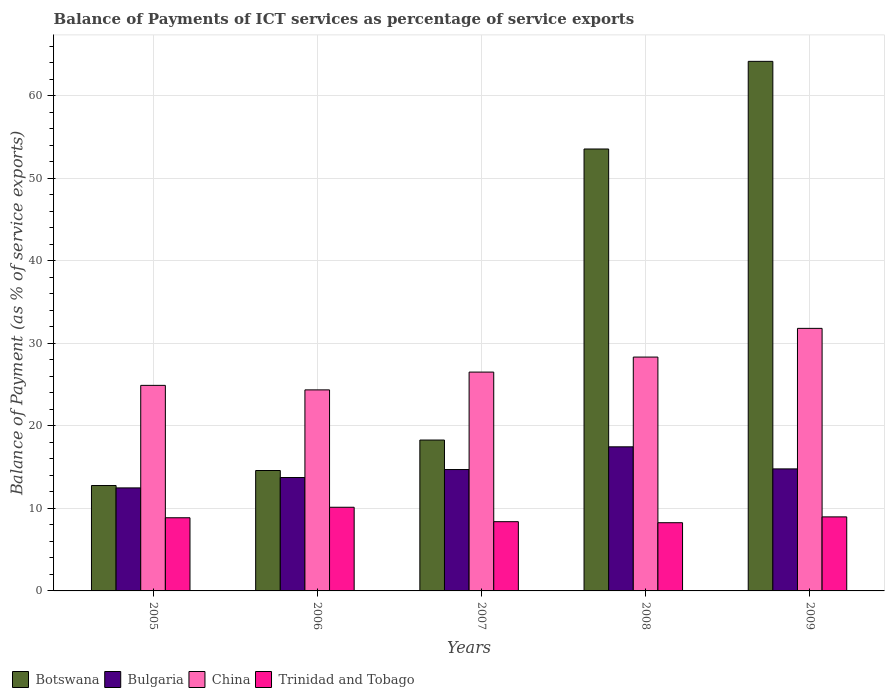How many different coloured bars are there?
Provide a short and direct response. 4. How many bars are there on the 5th tick from the right?
Make the answer very short. 4. What is the label of the 2nd group of bars from the left?
Provide a short and direct response. 2006. What is the balance of payments of ICT services in Botswana in 2007?
Your answer should be very brief. 18.28. Across all years, what is the maximum balance of payments of ICT services in Bulgaria?
Make the answer very short. 17.46. Across all years, what is the minimum balance of payments of ICT services in Botswana?
Give a very brief answer. 12.77. In which year was the balance of payments of ICT services in Bulgaria maximum?
Your response must be concise. 2008. In which year was the balance of payments of ICT services in Trinidad and Tobago minimum?
Offer a terse response. 2008. What is the total balance of payments of ICT services in Trinidad and Tobago in the graph?
Keep it short and to the point. 44.63. What is the difference between the balance of payments of ICT services in Bulgaria in 2005 and that in 2006?
Keep it short and to the point. -1.26. What is the difference between the balance of payments of ICT services in Bulgaria in 2005 and the balance of payments of ICT services in Trinidad and Tobago in 2009?
Give a very brief answer. 3.51. What is the average balance of payments of ICT services in China per year?
Ensure brevity in your answer.  27.18. In the year 2009, what is the difference between the balance of payments of ICT services in Bulgaria and balance of payments of ICT services in Trinidad and Tobago?
Offer a terse response. 5.81. What is the ratio of the balance of payments of ICT services in Bulgaria in 2005 to that in 2007?
Your answer should be compact. 0.85. Is the balance of payments of ICT services in Botswana in 2006 less than that in 2009?
Your answer should be compact. Yes. What is the difference between the highest and the second highest balance of payments of ICT services in Botswana?
Your response must be concise. 10.62. What is the difference between the highest and the lowest balance of payments of ICT services in Botswana?
Your answer should be compact. 51.39. In how many years, is the balance of payments of ICT services in Botswana greater than the average balance of payments of ICT services in Botswana taken over all years?
Your response must be concise. 2. Is it the case that in every year, the sum of the balance of payments of ICT services in Trinidad and Tobago and balance of payments of ICT services in Botswana is greater than the sum of balance of payments of ICT services in China and balance of payments of ICT services in Bulgaria?
Give a very brief answer. Yes. What does the 1st bar from the left in 2009 represents?
Make the answer very short. Botswana. What does the 2nd bar from the right in 2007 represents?
Offer a terse response. China. Is it the case that in every year, the sum of the balance of payments of ICT services in Botswana and balance of payments of ICT services in Bulgaria is greater than the balance of payments of ICT services in Trinidad and Tobago?
Ensure brevity in your answer.  Yes. How many bars are there?
Keep it short and to the point. 20. How many years are there in the graph?
Your response must be concise. 5. Are the values on the major ticks of Y-axis written in scientific E-notation?
Offer a very short reply. No. Does the graph contain any zero values?
Give a very brief answer. No. Where does the legend appear in the graph?
Ensure brevity in your answer.  Bottom left. How many legend labels are there?
Ensure brevity in your answer.  4. What is the title of the graph?
Your response must be concise. Balance of Payments of ICT services as percentage of service exports. Does "Cote d'Ivoire" appear as one of the legend labels in the graph?
Provide a succinct answer. No. What is the label or title of the X-axis?
Your answer should be very brief. Years. What is the label or title of the Y-axis?
Provide a succinct answer. Balance of Payment (as % of service exports). What is the Balance of Payment (as % of service exports) of Botswana in 2005?
Your answer should be very brief. 12.77. What is the Balance of Payment (as % of service exports) of Bulgaria in 2005?
Provide a short and direct response. 12.48. What is the Balance of Payment (as % of service exports) of China in 2005?
Your answer should be compact. 24.91. What is the Balance of Payment (as % of service exports) in Trinidad and Tobago in 2005?
Ensure brevity in your answer.  8.86. What is the Balance of Payment (as % of service exports) of Botswana in 2006?
Give a very brief answer. 14.59. What is the Balance of Payment (as % of service exports) in Bulgaria in 2006?
Provide a succinct answer. 13.74. What is the Balance of Payment (as % of service exports) of China in 2006?
Your answer should be very brief. 24.36. What is the Balance of Payment (as % of service exports) in Trinidad and Tobago in 2006?
Ensure brevity in your answer.  10.14. What is the Balance of Payment (as % of service exports) in Botswana in 2007?
Make the answer very short. 18.28. What is the Balance of Payment (as % of service exports) of Bulgaria in 2007?
Keep it short and to the point. 14.71. What is the Balance of Payment (as % of service exports) in China in 2007?
Provide a succinct answer. 26.51. What is the Balance of Payment (as % of service exports) of Trinidad and Tobago in 2007?
Your answer should be compact. 8.39. What is the Balance of Payment (as % of service exports) of Botswana in 2008?
Ensure brevity in your answer.  53.54. What is the Balance of Payment (as % of service exports) of Bulgaria in 2008?
Make the answer very short. 17.46. What is the Balance of Payment (as % of service exports) of China in 2008?
Make the answer very short. 28.33. What is the Balance of Payment (as % of service exports) in Trinidad and Tobago in 2008?
Offer a very short reply. 8.26. What is the Balance of Payment (as % of service exports) in Botswana in 2009?
Your answer should be very brief. 64.16. What is the Balance of Payment (as % of service exports) of Bulgaria in 2009?
Your answer should be very brief. 14.78. What is the Balance of Payment (as % of service exports) of China in 2009?
Your response must be concise. 31.81. What is the Balance of Payment (as % of service exports) of Trinidad and Tobago in 2009?
Offer a very short reply. 8.97. Across all years, what is the maximum Balance of Payment (as % of service exports) in Botswana?
Offer a terse response. 64.16. Across all years, what is the maximum Balance of Payment (as % of service exports) of Bulgaria?
Offer a very short reply. 17.46. Across all years, what is the maximum Balance of Payment (as % of service exports) in China?
Offer a very short reply. 31.81. Across all years, what is the maximum Balance of Payment (as % of service exports) of Trinidad and Tobago?
Provide a succinct answer. 10.14. Across all years, what is the minimum Balance of Payment (as % of service exports) in Botswana?
Give a very brief answer. 12.77. Across all years, what is the minimum Balance of Payment (as % of service exports) in Bulgaria?
Provide a succinct answer. 12.48. Across all years, what is the minimum Balance of Payment (as % of service exports) in China?
Provide a short and direct response. 24.36. Across all years, what is the minimum Balance of Payment (as % of service exports) in Trinidad and Tobago?
Your answer should be very brief. 8.26. What is the total Balance of Payment (as % of service exports) in Botswana in the graph?
Ensure brevity in your answer.  163.35. What is the total Balance of Payment (as % of service exports) in Bulgaria in the graph?
Offer a terse response. 73.17. What is the total Balance of Payment (as % of service exports) of China in the graph?
Provide a short and direct response. 135.92. What is the total Balance of Payment (as % of service exports) of Trinidad and Tobago in the graph?
Keep it short and to the point. 44.63. What is the difference between the Balance of Payment (as % of service exports) of Botswana in 2005 and that in 2006?
Make the answer very short. -1.82. What is the difference between the Balance of Payment (as % of service exports) of Bulgaria in 2005 and that in 2006?
Your answer should be very brief. -1.26. What is the difference between the Balance of Payment (as % of service exports) of China in 2005 and that in 2006?
Ensure brevity in your answer.  0.55. What is the difference between the Balance of Payment (as % of service exports) of Trinidad and Tobago in 2005 and that in 2006?
Offer a very short reply. -1.27. What is the difference between the Balance of Payment (as % of service exports) of Botswana in 2005 and that in 2007?
Your answer should be compact. -5.51. What is the difference between the Balance of Payment (as % of service exports) of Bulgaria in 2005 and that in 2007?
Offer a terse response. -2.23. What is the difference between the Balance of Payment (as % of service exports) of China in 2005 and that in 2007?
Ensure brevity in your answer.  -1.61. What is the difference between the Balance of Payment (as % of service exports) in Trinidad and Tobago in 2005 and that in 2007?
Make the answer very short. 0.47. What is the difference between the Balance of Payment (as % of service exports) of Botswana in 2005 and that in 2008?
Give a very brief answer. -40.77. What is the difference between the Balance of Payment (as % of service exports) of Bulgaria in 2005 and that in 2008?
Give a very brief answer. -4.98. What is the difference between the Balance of Payment (as % of service exports) of China in 2005 and that in 2008?
Offer a terse response. -3.43. What is the difference between the Balance of Payment (as % of service exports) of Trinidad and Tobago in 2005 and that in 2008?
Your answer should be compact. 0.6. What is the difference between the Balance of Payment (as % of service exports) in Botswana in 2005 and that in 2009?
Offer a terse response. -51.39. What is the difference between the Balance of Payment (as % of service exports) in Bulgaria in 2005 and that in 2009?
Offer a terse response. -2.3. What is the difference between the Balance of Payment (as % of service exports) in China in 2005 and that in 2009?
Provide a succinct answer. -6.91. What is the difference between the Balance of Payment (as % of service exports) in Trinidad and Tobago in 2005 and that in 2009?
Provide a succinct answer. -0.11. What is the difference between the Balance of Payment (as % of service exports) of Botswana in 2006 and that in 2007?
Give a very brief answer. -3.69. What is the difference between the Balance of Payment (as % of service exports) of Bulgaria in 2006 and that in 2007?
Offer a very short reply. -0.97. What is the difference between the Balance of Payment (as % of service exports) of China in 2006 and that in 2007?
Your answer should be compact. -2.16. What is the difference between the Balance of Payment (as % of service exports) of Trinidad and Tobago in 2006 and that in 2007?
Provide a succinct answer. 1.75. What is the difference between the Balance of Payment (as % of service exports) of Botswana in 2006 and that in 2008?
Your answer should be compact. -38.95. What is the difference between the Balance of Payment (as % of service exports) in Bulgaria in 2006 and that in 2008?
Provide a short and direct response. -3.72. What is the difference between the Balance of Payment (as % of service exports) of China in 2006 and that in 2008?
Provide a succinct answer. -3.98. What is the difference between the Balance of Payment (as % of service exports) in Trinidad and Tobago in 2006 and that in 2008?
Your answer should be compact. 1.87. What is the difference between the Balance of Payment (as % of service exports) of Botswana in 2006 and that in 2009?
Keep it short and to the point. -49.57. What is the difference between the Balance of Payment (as % of service exports) of Bulgaria in 2006 and that in 2009?
Give a very brief answer. -1.05. What is the difference between the Balance of Payment (as % of service exports) of China in 2006 and that in 2009?
Your answer should be very brief. -7.45. What is the difference between the Balance of Payment (as % of service exports) in Trinidad and Tobago in 2006 and that in 2009?
Your answer should be very brief. 1.17. What is the difference between the Balance of Payment (as % of service exports) of Botswana in 2007 and that in 2008?
Your answer should be compact. -35.26. What is the difference between the Balance of Payment (as % of service exports) in Bulgaria in 2007 and that in 2008?
Your response must be concise. -2.75. What is the difference between the Balance of Payment (as % of service exports) of China in 2007 and that in 2008?
Your answer should be very brief. -1.82. What is the difference between the Balance of Payment (as % of service exports) of Trinidad and Tobago in 2007 and that in 2008?
Your answer should be very brief. 0.12. What is the difference between the Balance of Payment (as % of service exports) in Botswana in 2007 and that in 2009?
Give a very brief answer. -45.88. What is the difference between the Balance of Payment (as % of service exports) in Bulgaria in 2007 and that in 2009?
Offer a terse response. -0.08. What is the difference between the Balance of Payment (as % of service exports) in China in 2007 and that in 2009?
Ensure brevity in your answer.  -5.3. What is the difference between the Balance of Payment (as % of service exports) of Trinidad and Tobago in 2007 and that in 2009?
Give a very brief answer. -0.58. What is the difference between the Balance of Payment (as % of service exports) in Botswana in 2008 and that in 2009?
Your response must be concise. -10.62. What is the difference between the Balance of Payment (as % of service exports) in Bulgaria in 2008 and that in 2009?
Provide a succinct answer. 2.67. What is the difference between the Balance of Payment (as % of service exports) in China in 2008 and that in 2009?
Provide a short and direct response. -3.48. What is the difference between the Balance of Payment (as % of service exports) in Trinidad and Tobago in 2008 and that in 2009?
Offer a very short reply. -0.7. What is the difference between the Balance of Payment (as % of service exports) in Botswana in 2005 and the Balance of Payment (as % of service exports) in Bulgaria in 2006?
Make the answer very short. -0.97. What is the difference between the Balance of Payment (as % of service exports) in Botswana in 2005 and the Balance of Payment (as % of service exports) in China in 2006?
Offer a terse response. -11.59. What is the difference between the Balance of Payment (as % of service exports) in Botswana in 2005 and the Balance of Payment (as % of service exports) in Trinidad and Tobago in 2006?
Offer a very short reply. 2.63. What is the difference between the Balance of Payment (as % of service exports) of Bulgaria in 2005 and the Balance of Payment (as % of service exports) of China in 2006?
Provide a succinct answer. -11.88. What is the difference between the Balance of Payment (as % of service exports) of Bulgaria in 2005 and the Balance of Payment (as % of service exports) of Trinidad and Tobago in 2006?
Give a very brief answer. 2.34. What is the difference between the Balance of Payment (as % of service exports) of China in 2005 and the Balance of Payment (as % of service exports) of Trinidad and Tobago in 2006?
Give a very brief answer. 14.77. What is the difference between the Balance of Payment (as % of service exports) of Botswana in 2005 and the Balance of Payment (as % of service exports) of Bulgaria in 2007?
Offer a terse response. -1.94. What is the difference between the Balance of Payment (as % of service exports) of Botswana in 2005 and the Balance of Payment (as % of service exports) of China in 2007?
Your answer should be very brief. -13.74. What is the difference between the Balance of Payment (as % of service exports) of Botswana in 2005 and the Balance of Payment (as % of service exports) of Trinidad and Tobago in 2007?
Offer a terse response. 4.38. What is the difference between the Balance of Payment (as % of service exports) in Bulgaria in 2005 and the Balance of Payment (as % of service exports) in China in 2007?
Ensure brevity in your answer.  -14.03. What is the difference between the Balance of Payment (as % of service exports) of Bulgaria in 2005 and the Balance of Payment (as % of service exports) of Trinidad and Tobago in 2007?
Ensure brevity in your answer.  4.09. What is the difference between the Balance of Payment (as % of service exports) in China in 2005 and the Balance of Payment (as % of service exports) in Trinidad and Tobago in 2007?
Ensure brevity in your answer.  16.52. What is the difference between the Balance of Payment (as % of service exports) in Botswana in 2005 and the Balance of Payment (as % of service exports) in Bulgaria in 2008?
Your answer should be compact. -4.69. What is the difference between the Balance of Payment (as % of service exports) in Botswana in 2005 and the Balance of Payment (as % of service exports) in China in 2008?
Keep it short and to the point. -15.56. What is the difference between the Balance of Payment (as % of service exports) of Botswana in 2005 and the Balance of Payment (as % of service exports) of Trinidad and Tobago in 2008?
Provide a succinct answer. 4.51. What is the difference between the Balance of Payment (as % of service exports) in Bulgaria in 2005 and the Balance of Payment (as % of service exports) in China in 2008?
Offer a very short reply. -15.85. What is the difference between the Balance of Payment (as % of service exports) of Bulgaria in 2005 and the Balance of Payment (as % of service exports) of Trinidad and Tobago in 2008?
Ensure brevity in your answer.  4.22. What is the difference between the Balance of Payment (as % of service exports) of China in 2005 and the Balance of Payment (as % of service exports) of Trinidad and Tobago in 2008?
Your answer should be very brief. 16.64. What is the difference between the Balance of Payment (as % of service exports) in Botswana in 2005 and the Balance of Payment (as % of service exports) in Bulgaria in 2009?
Give a very brief answer. -2.01. What is the difference between the Balance of Payment (as % of service exports) of Botswana in 2005 and the Balance of Payment (as % of service exports) of China in 2009?
Give a very brief answer. -19.04. What is the difference between the Balance of Payment (as % of service exports) in Botswana in 2005 and the Balance of Payment (as % of service exports) in Trinidad and Tobago in 2009?
Provide a short and direct response. 3.8. What is the difference between the Balance of Payment (as % of service exports) of Bulgaria in 2005 and the Balance of Payment (as % of service exports) of China in 2009?
Offer a very short reply. -19.33. What is the difference between the Balance of Payment (as % of service exports) in Bulgaria in 2005 and the Balance of Payment (as % of service exports) in Trinidad and Tobago in 2009?
Offer a terse response. 3.51. What is the difference between the Balance of Payment (as % of service exports) in China in 2005 and the Balance of Payment (as % of service exports) in Trinidad and Tobago in 2009?
Make the answer very short. 15.94. What is the difference between the Balance of Payment (as % of service exports) of Botswana in 2006 and the Balance of Payment (as % of service exports) of Bulgaria in 2007?
Offer a very short reply. -0.12. What is the difference between the Balance of Payment (as % of service exports) of Botswana in 2006 and the Balance of Payment (as % of service exports) of China in 2007?
Provide a succinct answer. -11.92. What is the difference between the Balance of Payment (as % of service exports) in Botswana in 2006 and the Balance of Payment (as % of service exports) in Trinidad and Tobago in 2007?
Offer a terse response. 6.2. What is the difference between the Balance of Payment (as % of service exports) of Bulgaria in 2006 and the Balance of Payment (as % of service exports) of China in 2007?
Keep it short and to the point. -12.78. What is the difference between the Balance of Payment (as % of service exports) of Bulgaria in 2006 and the Balance of Payment (as % of service exports) of Trinidad and Tobago in 2007?
Keep it short and to the point. 5.35. What is the difference between the Balance of Payment (as % of service exports) of China in 2006 and the Balance of Payment (as % of service exports) of Trinidad and Tobago in 2007?
Provide a succinct answer. 15.97. What is the difference between the Balance of Payment (as % of service exports) of Botswana in 2006 and the Balance of Payment (as % of service exports) of Bulgaria in 2008?
Provide a succinct answer. -2.87. What is the difference between the Balance of Payment (as % of service exports) in Botswana in 2006 and the Balance of Payment (as % of service exports) in China in 2008?
Your answer should be very brief. -13.74. What is the difference between the Balance of Payment (as % of service exports) in Botswana in 2006 and the Balance of Payment (as % of service exports) in Trinidad and Tobago in 2008?
Make the answer very short. 6.33. What is the difference between the Balance of Payment (as % of service exports) in Bulgaria in 2006 and the Balance of Payment (as % of service exports) in China in 2008?
Ensure brevity in your answer.  -14.6. What is the difference between the Balance of Payment (as % of service exports) in Bulgaria in 2006 and the Balance of Payment (as % of service exports) in Trinidad and Tobago in 2008?
Offer a very short reply. 5.47. What is the difference between the Balance of Payment (as % of service exports) of China in 2006 and the Balance of Payment (as % of service exports) of Trinidad and Tobago in 2008?
Provide a succinct answer. 16.09. What is the difference between the Balance of Payment (as % of service exports) of Botswana in 2006 and the Balance of Payment (as % of service exports) of Bulgaria in 2009?
Provide a succinct answer. -0.19. What is the difference between the Balance of Payment (as % of service exports) in Botswana in 2006 and the Balance of Payment (as % of service exports) in China in 2009?
Offer a terse response. -17.22. What is the difference between the Balance of Payment (as % of service exports) in Botswana in 2006 and the Balance of Payment (as % of service exports) in Trinidad and Tobago in 2009?
Provide a succinct answer. 5.62. What is the difference between the Balance of Payment (as % of service exports) of Bulgaria in 2006 and the Balance of Payment (as % of service exports) of China in 2009?
Provide a succinct answer. -18.07. What is the difference between the Balance of Payment (as % of service exports) of Bulgaria in 2006 and the Balance of Payment (as % of service exports) of Trinidad and Tobago in 2009?
Ensure brevity in your answer.  4.77. What is the difference between the Balance of Payment (as % of service exports) of China in 2006 and the Balance of Payment (as % of service exports) of Trinidad and Tobago in 2009?
Your answer should be compact. 15.39. What is the difference between the Balance of Payment (as % of service exports) of Botswana in 2007 and the Balance of Payment (as % of service exports) of Bulgaria in 2008?
Keep it short and to the point. 0.82. What is the difference between the Balance of Payment (as % of service exports) of Botswana in 2007 and the Balance of Payment (as % of service exports) of China in 2008?
Your response must be concise. -10.05. What is the difference between the Balance of Payment (as % of service exports) in Botswana in 2007 and the Balance of Payment (as % of service exports) in Trinidad and Tobago in 2008?
Ensure brevity in your answer.  10.02. What is the difference between the Balance of Payment (as % of service exports) of Bulgaria in 2007 and the Balance of Payment (as % of service exports) of China in 2008?
Your answer should be compact. -13.63. What is the difference between the Balance of Payment (as % of service exports) of Bulgaria in 2007 and the Balance of Payment (as % of service exports) of Trinidad and Tobago in 2008?
Keep it short and to the point. 6.44. What is the difference between the Balance of Payment (as % of service exports) of China in 2007 and the Balance of Payment (as % of service exports) of Trinidad and Tobago in 2008?
Keep it short and to the point. 18.25. What is the difference between the Balance of Payment (as % of service exports) in Botswana in 2007 and the Balance of Payment (as % of service exports) in Bulgaria in 2009?
Your answer should be very brief. 3.5. What is the difference between the Balance of Payment (as % of service exports) in Botswana in 2007 and the Balance of Payment (as % of service exports) in China in 2009?
Provide a short and direct response. -13.53. What is the difference between the Balance of Payment (as % of service exports) in Botswana in 2007 and the Balance of Payment (as % of service exports) in Trinidad and Tobago in 2009?
Your response must be concise. 9.31. What is the difference between the Balance of Payment (as % of service exports) of Bulgaria in 2007 and the Balance of Payment (as % of service exports) of China in 2009?
Offer a terse response. -17.1. What is the difference between the Balance of Payment (as % of service exports) of Bulgaria in 2007 and the Balance of Payment (as % of service exports) of Trinidad and Tobago in 2009?
Your response must be concise. 5.74. What is the difference between the Balance of Payment (as % of service exports) in China in 2007 and the Balance of Payment (as % of service exports) in Trinidad and Tobago in 2009?
Ensure brevity in your answer.  17.54. What is the difference between the Balance of Payment (as % of service exports) of Botswana in 2008 and the Balance of Payment (as % of service exports) of Bulgaria in 2009?
Your response must be concise. 38.76. What is the difference between the Balance of Payment (as % of service exports) in Botswana in 2008 and the Balance of Payment (as % of service exports) in China in 2009?
Ensure brevity in your answer.  21.73. What is the difference between the Balance of Payment (as % of service exports) in Botswana in 2008 and the Balance of Payment (as % of service exports) in Trinidad and Tobago in 2009?
Make the answer very short. 44.57. What is the difference between the Balance of Payment (as % of service exports) of Bulgaria in 2008 and the Balance of Payment (as % of service exports) of China in 2009?
Offer a very short reply. -14.35. What is the difference between the Balance of Payment (as % of service exports) in Bulgaria in 2008 and the Balance of Payment (as % of service exports) in Trinidad and Tobago in 2009?
Ensure brevity in your answer.  8.49. What is the difference between the Balance of Payment (as % of service exports) in China in 2008 and the Balance of Payment (as % of service exports) in Trinidad and Tobago in 2009?
Provide a short and direct response. 19.36. What is the average Balance of Payment (as % of service exports) of Botswana per year?
Your answer should be compact. 32.67. What is the average Balance of Payment (as % of service exports) of Bulgaria per year?
Provide a succinct answer. 14.63. What is the average Balance of Payment (as % of service exports) of China per year?
Give a very brief answer. 27.18. What is the average Balance of Payment (as % of service exports) in Trinidad and Tobago per year?
Ensure brevity in your answer.  8.93. In the year 2005, what is the difference between the Balance of Payment (as % of service exports) in Botswana and Balance of Payment (as % of service exports) in Bulgaria?
Keep it short and to the point. 0.29. In the year 2005, what is the difference between the Balance of Payment (as % of service exports) in Botswana and Balance of Payment (as % of service exports) in China?
Give a very brief answer. -12.13. In the year 2005, what is the difference between the Balance of Payment (as % of service exports) in Botswana and Balance of Payment (as % of service exports) in Trinidad and Tobago?
Your response must be concise. 3.91. In the year 2005, what is the difference between the Balance of Payment (as % of service exports) in Bulgaria and Balance of Payment (as % of service exports) in China?
Your response must be concise. -12.42. In the year 2005, what is the difference between the Balance of Payment (as % of service exports) in Bulgaria and Balance of Payment (as % of service exports) in Trinidad and Tobago?
Your response must be concise. 3.62. In the year 2005, what is the difference between the Balance of Payment (as % of service exports) in China and Balance of Payment (as % of service exports) in Trinidad and Tobago?
Your answer should be compact. 16.04. In the year 2006, what is the difference between the Balance of Payment (as % of service exports) in Botswana and Balance of Payment (as % of service exports) in Bulgaria?
Your response must be concise. 0.85. In the year 2006, what is the difference between the Balance of Payment (as % of service exports) in Botswana and Balance of Payment (as % of service exports) in China?
Your answer should be compact. -9.77. In the year 2006, what is the difference between the Balance of Payment (as % of service exports) in Botswana and Balance of Payment (as % of service exports) in Trinidad and Tobago?
Provide a short and direct response. 4.45. In the year 2006, what is the difference between the Balance of Payment (as % of service exports) of Bulgaria and Balance of Payment (as % of service exports) of China?
Offer a terse response. -10.62. In the year 2006, what is the difference between the Balance of Payment (as % of service exports) of Bulgaria and Balance of Payment (as % of service exports) of Trinidad and Tobago?
Provide a short and direct response. 3.6. In the year 2006, what is the difference between the Balance of Payment (as % of service exports) in China and Balance of Payment (as % of service exports) in Trinidad and Tobago?
Your answer should be very brief. 14.22. In the year 2007, what is the difference between the Balance of Payment (as % of service exports) in Botswana and Balance of Payment (as % of service exports) in Bulgaria?
Your response must be concise. 3.57. In the year 2007, what is the difference between the Balance of Payment (as % of service exports) in Botswana and Balance of Payment (as % of service exports) in China?
Your response must be concise. -8.23. In the year 2007, what is the difference between the Balance of Payment (as % of service exports) in Botswana and Balance of Payment (as % of service exports) in Trinidad and Tobago?
Make the answer very short. 9.89. In the year 2007, what is the difference between the Balance of Payment (as % of service exports) in Bulgaria and Balance of Payment (as % of service exports) in China?
Your response must be concise. -11.81. In the year 2007, what is the difference between the Balance of Payment (as % of service exports) of Bulgaria and Balance of Payment (as % of service exports) of Trinidad and Tobago?
Your answer should be very brief. 6.32. In the year 2007, what is the difference between the Balance of Payment (as % of service exports) of China and Balance of Payment (as % of service exports) of Trinidad and Tobago?
Your response must be concise. 18.12. In the year 2008, what is the difference between the Balance of Payment (as % of service exports) in Botswana and Balance of Payment (as % of service exports) in Bulgaria?
Make the answer very short. 36.09. In the year 2008, what is the difference between the Balance of Payment (as % of service exports) in Botswana and Balance of Payment (as % of service exports) in China?
Ensure brevity in your answer.  25.21. In the year 2008, what is the difference between the Balance of Payment (as % of service exports) in Botswana and Balance of Payment (as % of service exports) in Trinidad and Tobago?
Offer a very short reply. 45.28. In the year 2008, what is the difference between the Balance of Payment (as % of service exports) of Bulgaria and Balance of Payment (as % of service exports) of China?
Your answer should be compact. -10.88. In the year 2008, what is the difference between the Balance of Payment (as % of service exports) of Bulgaria and Balance of Payment (as % of service exports) of Trinidad and Tobago?
Keep it short and to the point. 9.19. In the year 2008, what is the difference between the Balance of Payment (as % of service exports) of China and Balance of Payment (as % of service exports) of Trinidad and Tobago?
Offer a terse response. 20.07. In the year 2009, what is the difference between the Balance of Payment (as % of service exports) in Botswana and Balance of Payment (as % of service exports) in Bulgaria?
Your answer should be very brief. 49.38. In the year 2009, what is the difference between the Balance of Payment (as % of service exports) in Botswana and Balance of Payment (as % of service exports) in China?
Ensure brevity in your answer.  32.35. In the year 2009, what is the difference between the Balance of Payment (as % of service exports) of Botswana and Balance of Payment (as % of service exports) of Trinidad and Tobago?
Your response must be concise. 55.19. In the year 2009, what is the difference between the Balance of Payment (as % of service exports) of Bulgaria and Balance of Payment (as % of service exports) of China?
Provide a short and direct response. -17.03. In the year 2009, what is the difference between the Balance of Payment (as % of service exports) in Bulgaria and Balance of Payment (as % of service exports) in Trinidad and Tobago?
Your answer should be compact. 5.82. In the year 2009, what is the difference between the Balance of Payment (as % of service exports) in China and Balance of Payment (as % of service exports) in Trinidad and Tobago?
Your answer should be very brief. 22.84. What is the ratio of the Balance of Payment (as % of service exports) in Botswana in 2005 to that in 2006?
Ensure brevity in your answer.  0.88. What is the ratio of the Balance of Payment (as % of service exports) of Bulgaria in 2005 to that in 2006?
Your answer should be very brief. 0.91. What is the ratio of the Balance of Payment (as % of service exports) of China in 2005 to that in 2006?
Make the answer very short. 1.02. What is the ratio of the Balance of Payment (as % of service exports) in Trinidad and Tobago in 2005 to that in 2006?
Offer a terse response. 0.87. What is the ratio of the Balance of Payment (as % of service exports) of Botswana in 2005 to that in 2007?
Your answer should be very brief. 0.7. What is the ratio of the Balance of Payment (as % of service exports) of Bulgaria in 2005 to that in 2007?
Your answer should be compact. 0.85. What is the ratio of the Balance of Payment (as % of service exports) of China in 2005 to that in 2007?
Make the answer very short. 0.94. What is the ratio of the Balance of Payment (as % of service exports) of Trinidad and Tobago in 2005 to that in 2007?
Your response must be concise. 1.06. What is the ratio of the Balance of Payment (as % of service exports) in Botswana in 2005 to that in 2008?
Provide a succinct answer. 0.24. What is the ratio of the Balance of Payment (as % of service exports) in Bulgaria in 2005 to that in 2008?
Your answer should be compact. 0.71. What is the ratio of the Balance of Payment (as % of service exports) in China in 2005 to that in 2008?
Provide a short and direct response. 0.88. What is the ratio of the Balance of Payment (as % of service exports) in Trinidad and Tobago in 2005 to that in 2008?
Give a very brief answer. 1.07. What is the ratio of the Balance of Payment (as % of service exports) in Botswana in 2005 to that in 2009?
Your answer should be very brief. 0.2. What is the ratio of the Balance of Payment (as % of service exports) of Bulgaria in 2005 to that in 2009?
Provide a succinct answer. 0.84. What is the ratio of the Balance of Payment (as % of service exports) of China in 2005 to that in 2009?
Offer a terse response. 0.78. What is the ratio of the Balance of Payment (as % of service exports) in Botswana in 2006 to that in 2007?
Give a very brief answer. 0.8. What is the ratio of the Balance of Payment (as % of service exports) of Bulgaria in 2006 to that in 2007?
Ensure brevity in your answer.  0.93. What is the ratio of the Balance of Payment (as % of service exports) of China in 2006 to that in 2007?
Your answer should be very brief. 0.92. What is the ratio of the Balance of Payment (as % of service exports) of Trinidad and Tobago in 2006 to that in 2007?
Offer a very short reply. 1.21. What is the ratio of the Balance of Payment (as % of service exports) in Botswana in 2006 to that in 2008?
Your answer should be compact. 0.27. What is the ratio of the Balance of Payment (as % of service exports) of Bulgaria in 2006 to that in 2008?
Ensure brevity in your answer.  0.79. What is the ratio of the Balance of Payment (as % of service exports) in China in 2006 to that in 2008?
Ensure brevity in your answer.  0.86. What is the ratio of the Balance of Payment (as % of service exports) in Trinidad and Tobago in 2006 to that in 2008?
Your answer should be compact. 1.23. What is the ratio of the Balance of Payment (as % of service exports) in Botswana in 2006 to that in 2009?
Offer a very short reply. 0.23. What is the ratio of the Balance of Payment (as % of service exports) in Bulgaria in 2006 to that in 2009?
Your response must be concise. 0.93. What is the ratio of the Balance of Payment (as % of service exports) in China in 2006 to that in 2009?
Your response must be concise. 0.77. What is the ratio of the Balance of Payment (as % of service exports) of Trinidad and Tobago in 2006 to that in 2009?
Keep it short and to the point. 1.13. What is the ratio of the Balance of Payment (as % of service exports) of Botswana in 2007 to that in 2008?
Your response must be concise. 0.34. What is the ratio of the Balance of Payment (as % of service exports) of Bulgaria in 2007 to that in 2008?
Provide a succinct answer. 0.84. What is the ratio of the Balance of Payment (as % of service exports) in China in 2007 to that in 2008?
Make the answer very short. 0.94. What is the ratio of the Balance of Payment (as % of service exports) of Trinidad and Tobago in 2007 to that in 2008?
Offer a very short reply. 1.02. What is the ratio of the Balance of Payment (as % of service exports) of Botswana in 2007 to that in 2009?
Offer a terse response. 0.28. What is the ratio of the Balance of Payment (as % of service exports) of China in 2007 to that in 2009?
Make the answer very short. 0.83. What is the ratio of the Balance of Payment (as % of service exports) of Trinidad and Tobago in 2007 to that in 2009?
Give a very brief answer. 0.94. What is the ratio of the Balance of Payment (as % of service exports) of Botswana in 2008 to that in 2009?
Provide a short and direct response. 0.83. What is the ratio of the Balance of Payment (as % of service exports) in Bulgaria in 2008 to that in 2009?
Your response must be concise. 1.18. What is the ratio of the Balance of Payment (as % of service exports) of China in 2008 to that in 2009?
Make the answer very short. 0.89. What is the ratio of the Balance of Payment (as % of service exports) of Trinidad and Tobago in 2008 to that in 2009?
Your response must be concise. 0.92. What is the difference between the highest and the second highest Balance of Payment (as % of service exports) in Botswana?
Offer a very short reply. 10.62. What is the difference between the highest and the second highest Balance of Payment (as % of service exports) in Bulgaria?
Provide a short and direct response. 2.67. What is the difference between the highest and the second highest Balance of Payment (as % of service exports) of China?
Give a very brief answer. 3.48. What is the difference between the highest and the second highest Balance of Payment (as % of service exports) of Trinidad and Tobago?
Keep it short and to the point. 1.17. What is the difference between the highest and the lowest Balance of Payment (as % of service exports) of Botswana?
Your response must be concise. 51.39. What is the difference between the highest and the lowest Balance of Payment (as % of service exports) of Bulgaria?
Ensure brevity in your answer.  4.98. What is the difference between the highest and the lowest Balance of Payment (as % of service exports) in China?
Offer a terse response. 7.45. What is the difference between the highest and the lowest Balance of Payment (as % of service exports) in Trinidad and Tobago?
Your response must be concise. 1.87. 